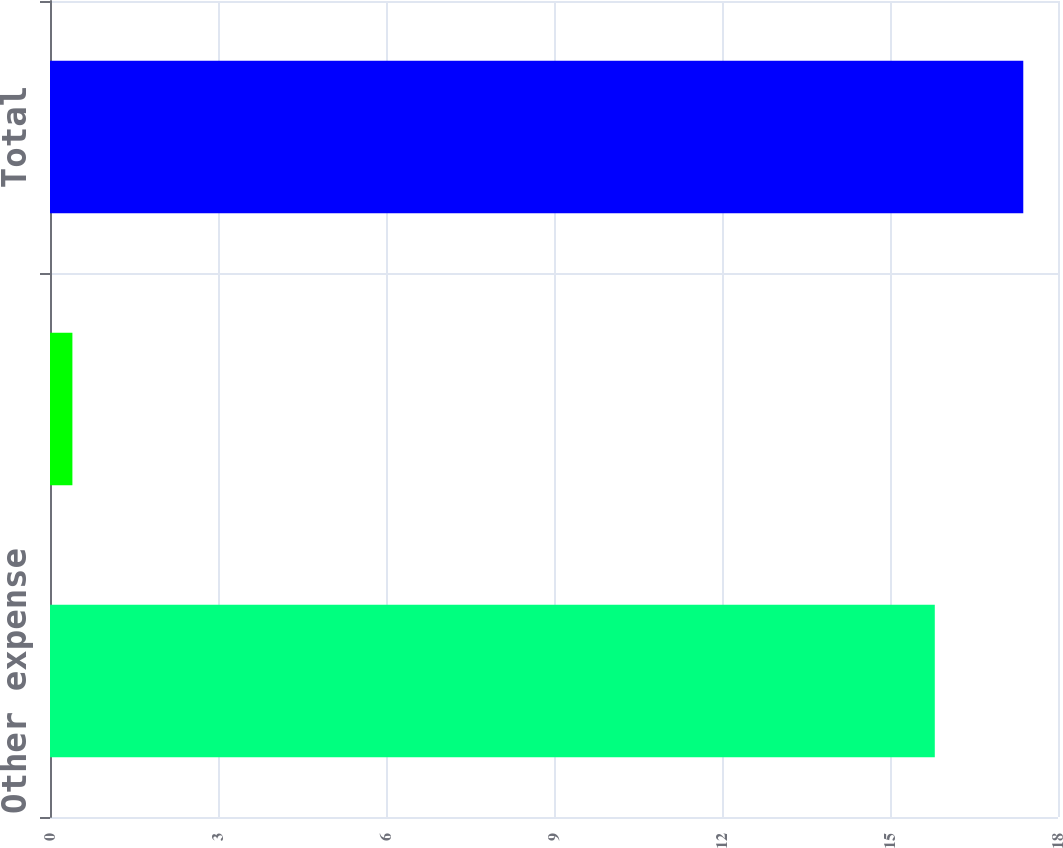Convert chart. <chart><loc_0><loc_0><loc_500><loc_500><bar_chart><fcel>Other expense<fcel>Cost of sales<fcel>Total<nl><fcel>15.8<fcel>0.4<fcel>17.38<nl></chart> 